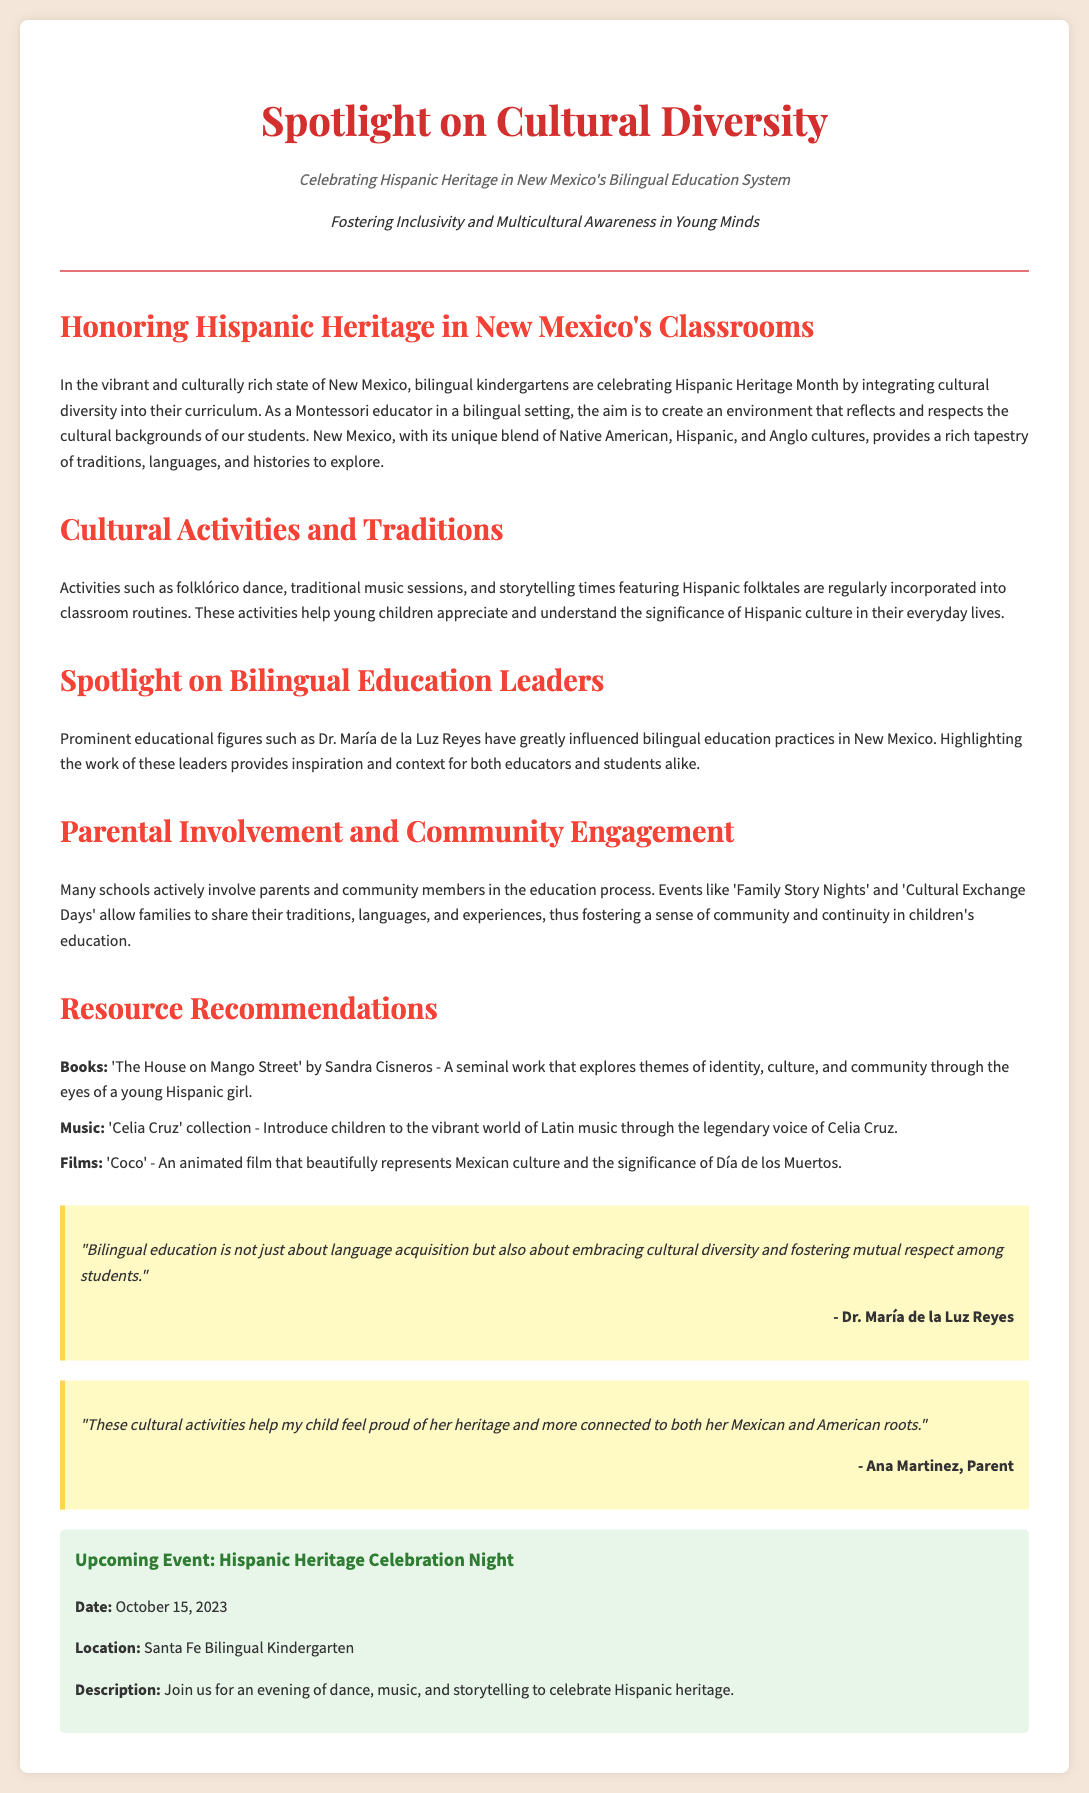what is the title of the article? The title of the article is prominently displayed in the header section, "Spotlight on Cultural Diversity".
Answer: Spotlight on Cultural Diversity what is the subtitle of the article? The subtitle explains the focus of the article and is found just below the title, "Celebrating Hispanic Heritage in New Mexico's Bilingual Education System."
Answer: Celebrating Hispanic Heritage in New Mexico's Bilingual Education System who is highlighted as an influential figure in bilingual education? The article mentions a prominent educational figure in bilingual education, providing her name as an example of influence.
Answer: Dr. María de la Luz Reyes what is one of the activities mentioned in the document? The document lists various cultural activities integrated into classrooms that promote understanding and appreciation of Hispanic culture.
Answer: folklórico dance what is the date of the upcoming event? The event details include a specific date when it will take place, listed in the document.
Answer: October 15, 2023 which school is hosting the upcoming event? The location of the event is explicitly stated in the event details within the document.
Answer: Santa Fe Bilingual Kindergarten what type of activities are included in the cultural celebration? The article describes the nature of activities included in the Hispanic Heritage Celebration Night, focusing on the experience to be had.
Answer: dance, music, and storytelling how do parents contribute to the education process, according to the article? The article emphasizes the role of parents and community members in specific events designed to enhance their children's education.
Answer: Family Story Nights and Cultural Exchange Days what is the primary message conveyed by Dr. María de la Luz Reyes' quote? The quote from Dr. Reyes reflects her views on what bilingual education encompasses, focusing on cultural aspects.
Answer: embracing cultural diversity and fostering mutual respect among students 